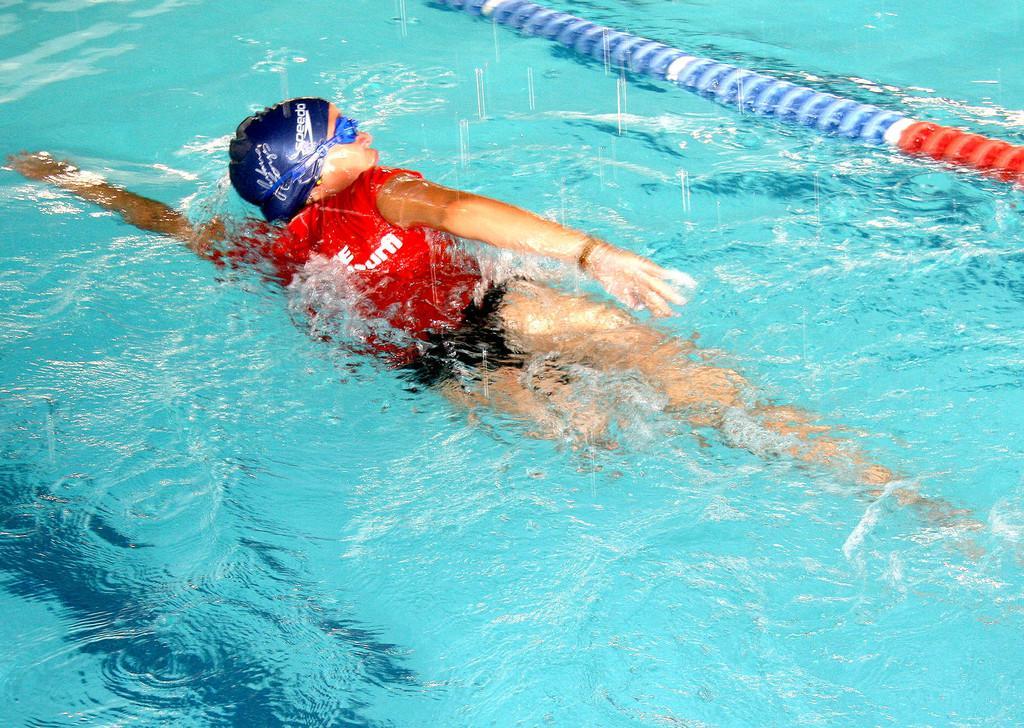Can you describe this image briefly? In this image we can see a person is swimming. We can see a pipe at the top of the image. 